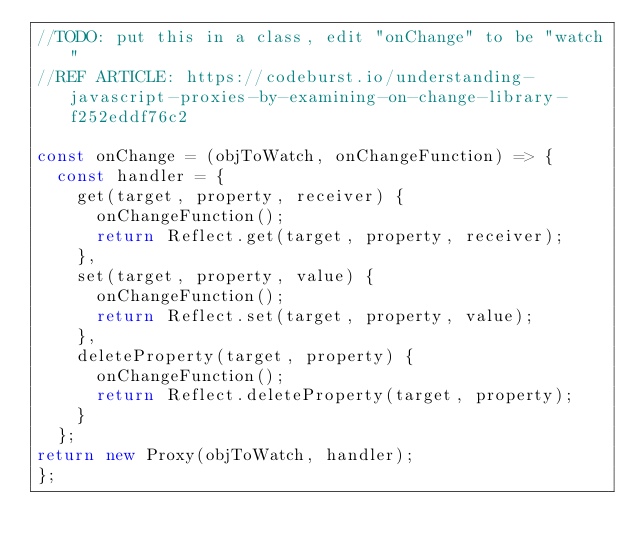<code> <loc_0><loc_0><loc_500><loc_500><_JavaScript_>//TODO: put this in a class, edit "onChange" to be "watch" 
//REF ARTICLE: https://codeburst.io/understanding-javascript-proxies-by-examining-on-change-library-f252eddf76c2

const onChange = (objToWatch, onChangeFunction) => { 
  const handler = {
    get(target, property, receiver) {
      onChangeFunction();
      return Reflect.get(target, property, receiver);
    },
    set(target, property, value) {
      onChangeFunction();
      return Reflect.set(target, property, value);
    },
    deleteProperty(target, property) {
      onChangeFunction();
      return Reflect.deleteProperty(target, property);
    }
  };
return new Proxy(objToWatch, handler);
};</code> 